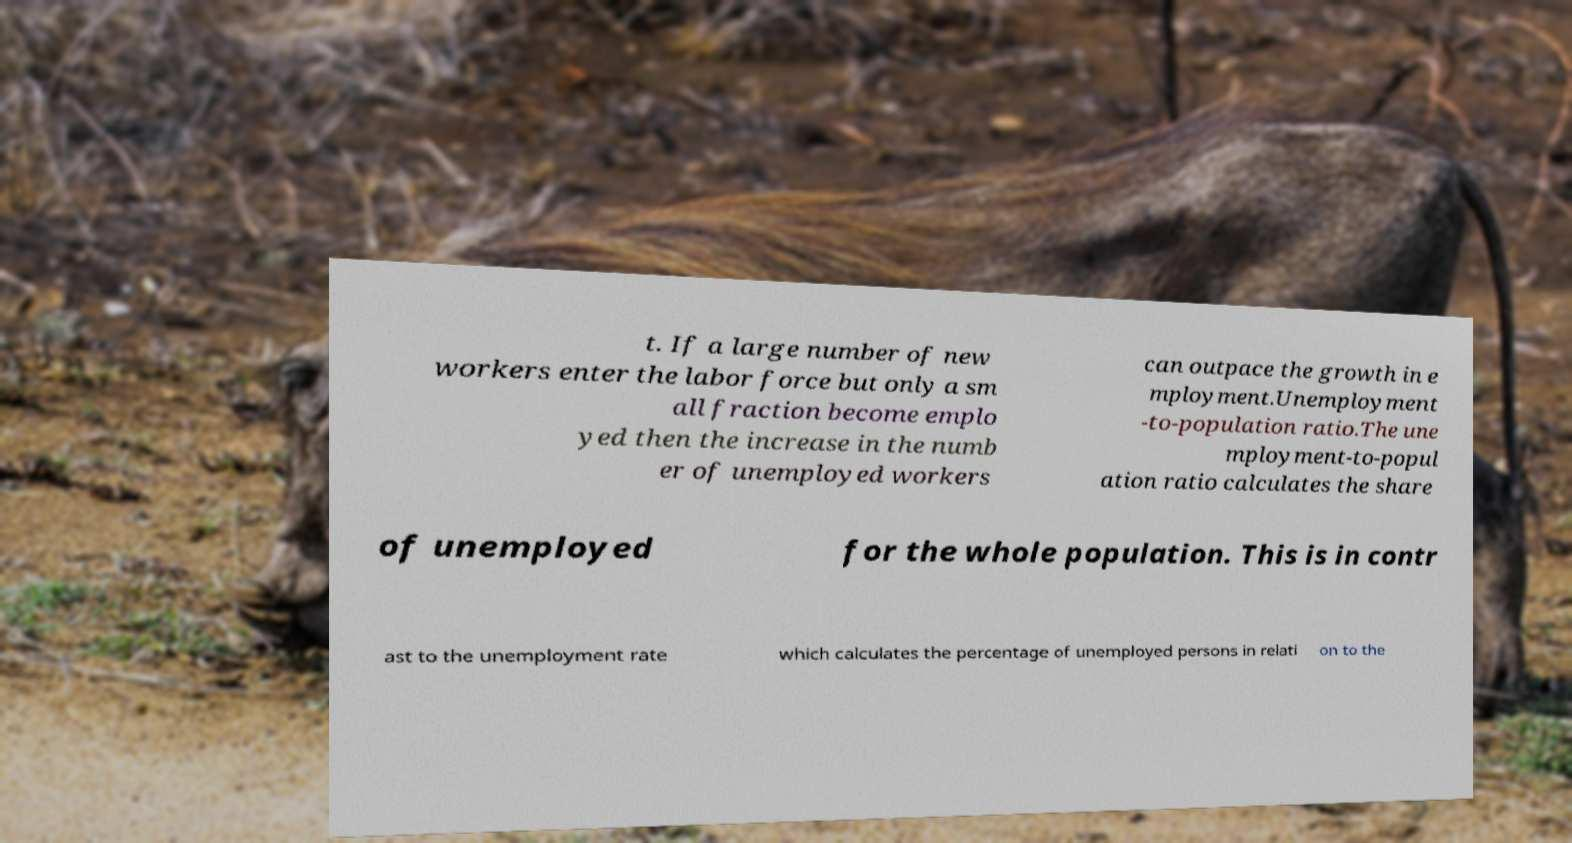For documentation purposes, I need the text within this image transcribed. Could you provide that? t. If a large number of new workers enter the labor force but only a sm all fraction become emplo yed then the increase in the numb er of unemployed workers can outpace the growth in e mployment.Unemployment -to-population ratio.The une mployment-to-popul ation ratio calculates the share of unemployed for the whole population. This is in contr ast to the unemployment rate which calculates the percentage of unemployed persons in relati on to the 